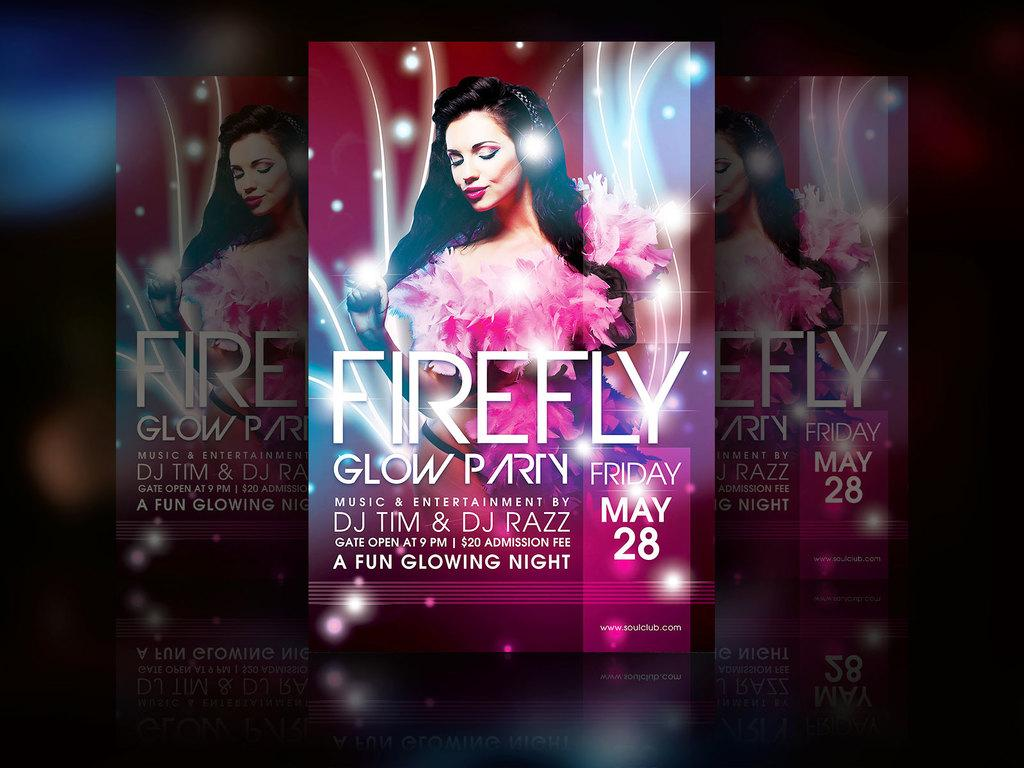<image>
Offer a succinct explanation of the picture presented. a Firefly glow party advertisement on a paper 